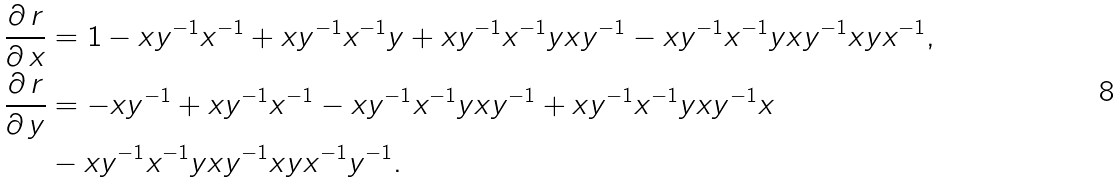<formula> <loc_0><loc_0><loc_500><loc_500>\frac { \partial \, r } { \partial \, x } & = 1 - x y ^ { - 1 } x ^ { - 1 } + x y ^ { - 1 } x ^ { - 1 } y + x y ^ { - 1 } x ^ { - 1 } y x y ^ { - 1 } - x y ^ { - 1 } x ^ { - 1 } y x y ^ { - 1 } x y x ^ { - 1 } , \\ \frac { \partial \, r } { \partial \, y } & = - x y ^ { - 1 } + x y ^ { - 1 } x ^ { - 1 } - x y ^ { - 1 } x ^ { - 1 } y x y ^ { - 1 } + x y ^ { - 1 } x ^ { - 1 } y x y ^ { - 1 } x \\ & - x y ^ { - 1 } x ^ { - 1 } y x y ^ { - 1 } x y x ^ { - 1 } y ^ { - 1 } .</formula> 